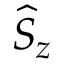Convert formula to latex. <formula><loc_0><loc_0><loc_500><loc_500>\widehat { S } _ { z }</formula> 